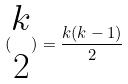<formula> <loc_0><loc_0><loc_500><loc_500>( \begin{matrix} k \\ 2 \end{matrix} ) = \frac { k ( k - 1 ) } { 2 }</formula> 